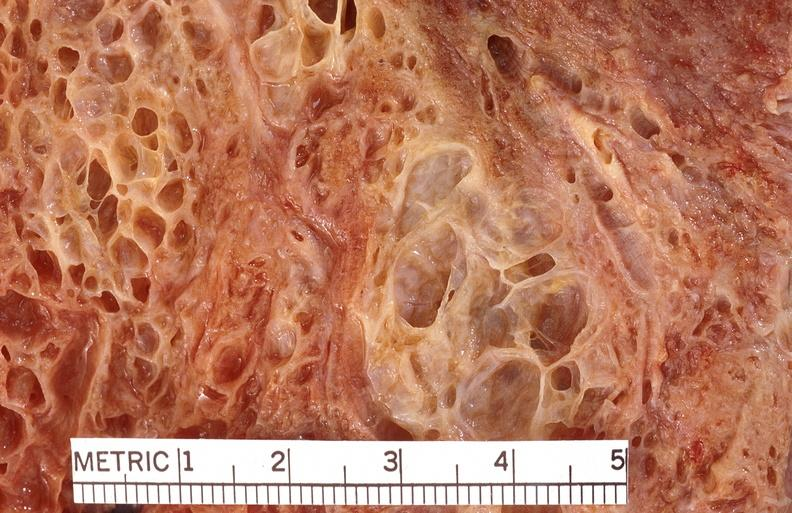what does this image show?
Answer the question using a single word or phrase. Lung fibrosis 